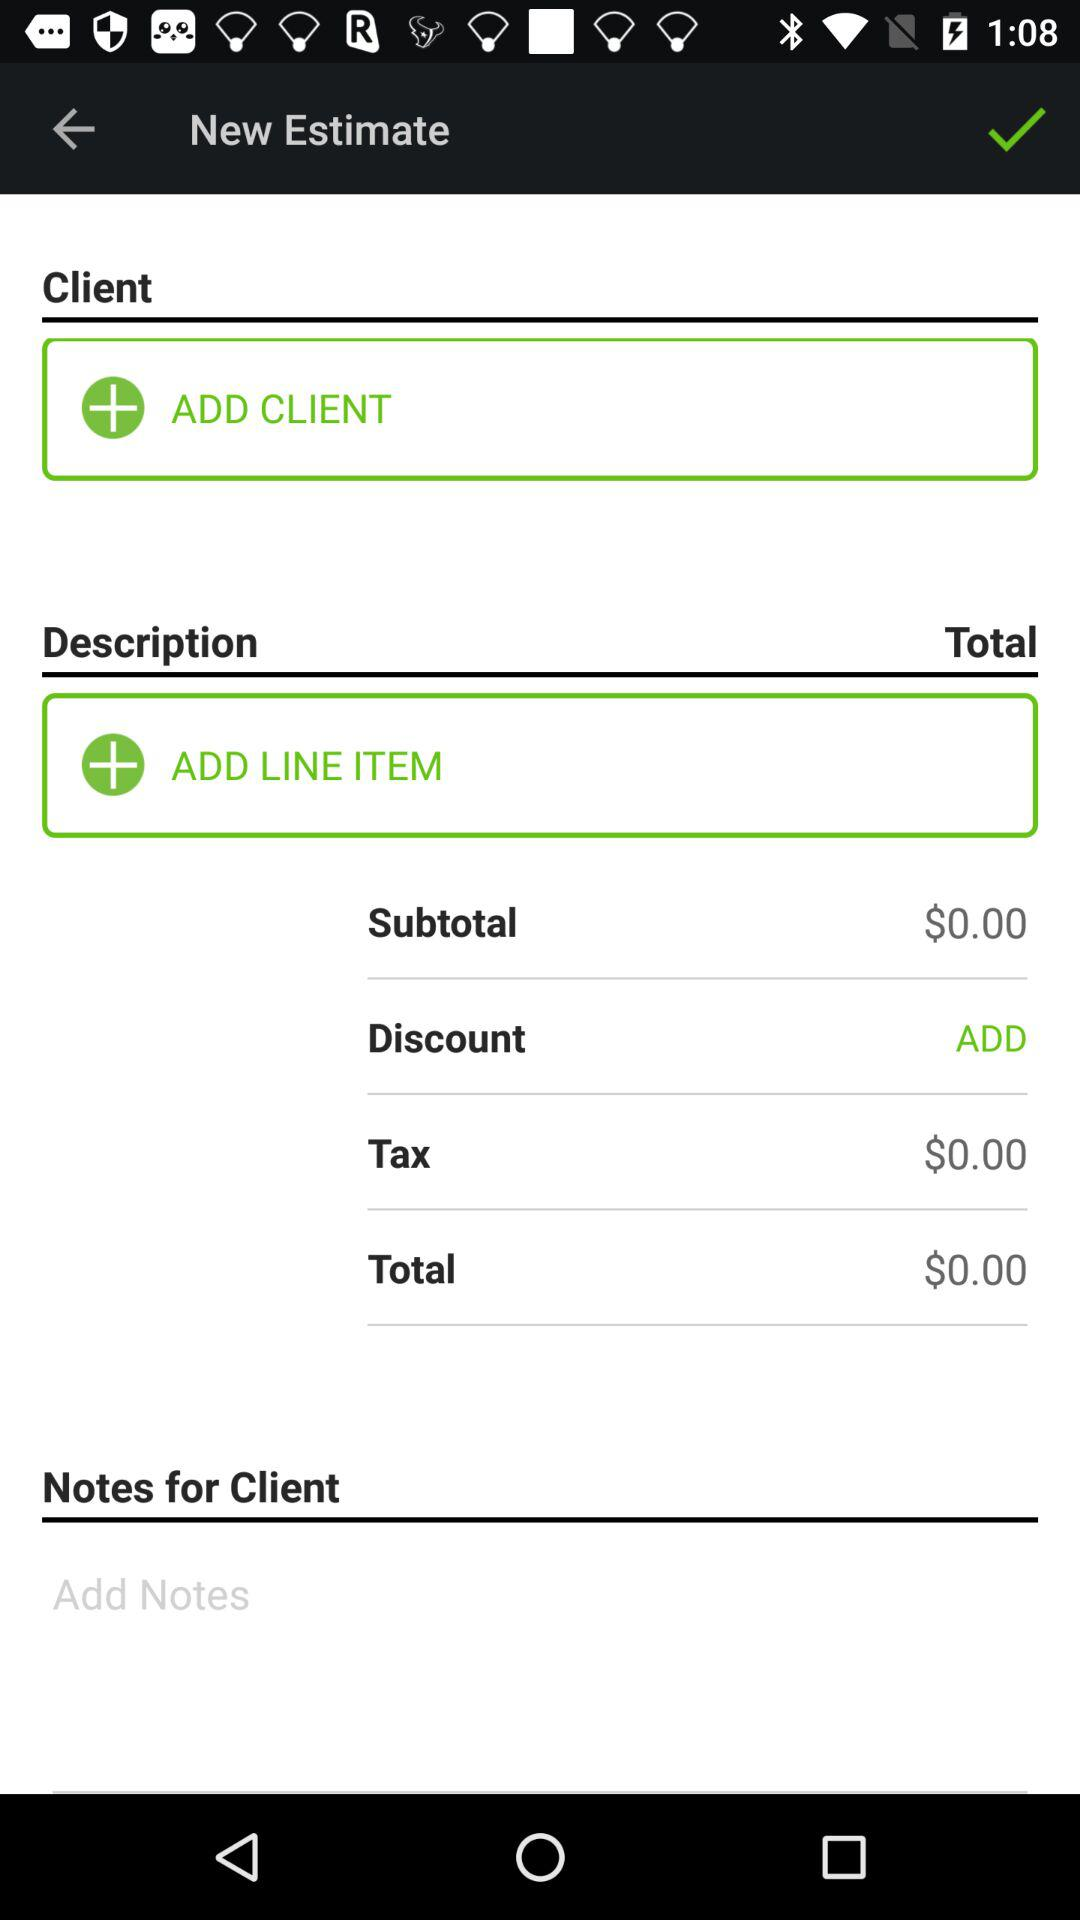How much will be paid as a tax? The amount of $0 will be paid as a tax. 